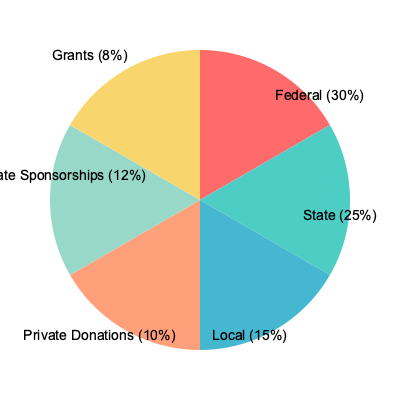In the pie chart depicting various sources of funding for social programs, what percentage of the total funding comes from non-governmental sources? To determine the percentage of funding from non-governmental sources, we need to follow these steps:

1. Identify the non-governmental sources:
   - Private Donations (10%)
   - Corporate Sponsorships (12%)
   - Grants (8%)

2. Sum up the percentages of these non-governmental sources:
   $10\% + 12\% + 8\% = 30\%$

3. Verify the result:
   Governmental sources (Federal + State + Local) = $30\% + 25\% + 15\% = 70\%$
   Total of all sources = $70\% + 30\% = 100\%$

4. Conclusion:
   The percentage of total funding from non-governmental sources is 30%.

This analysis is particularly relevant for a sociology major studying the distribution of funding for social programs, as it highlights the significant role of both governmental and non-governmental entities in supporting these initiatives.
Answer: 30% 